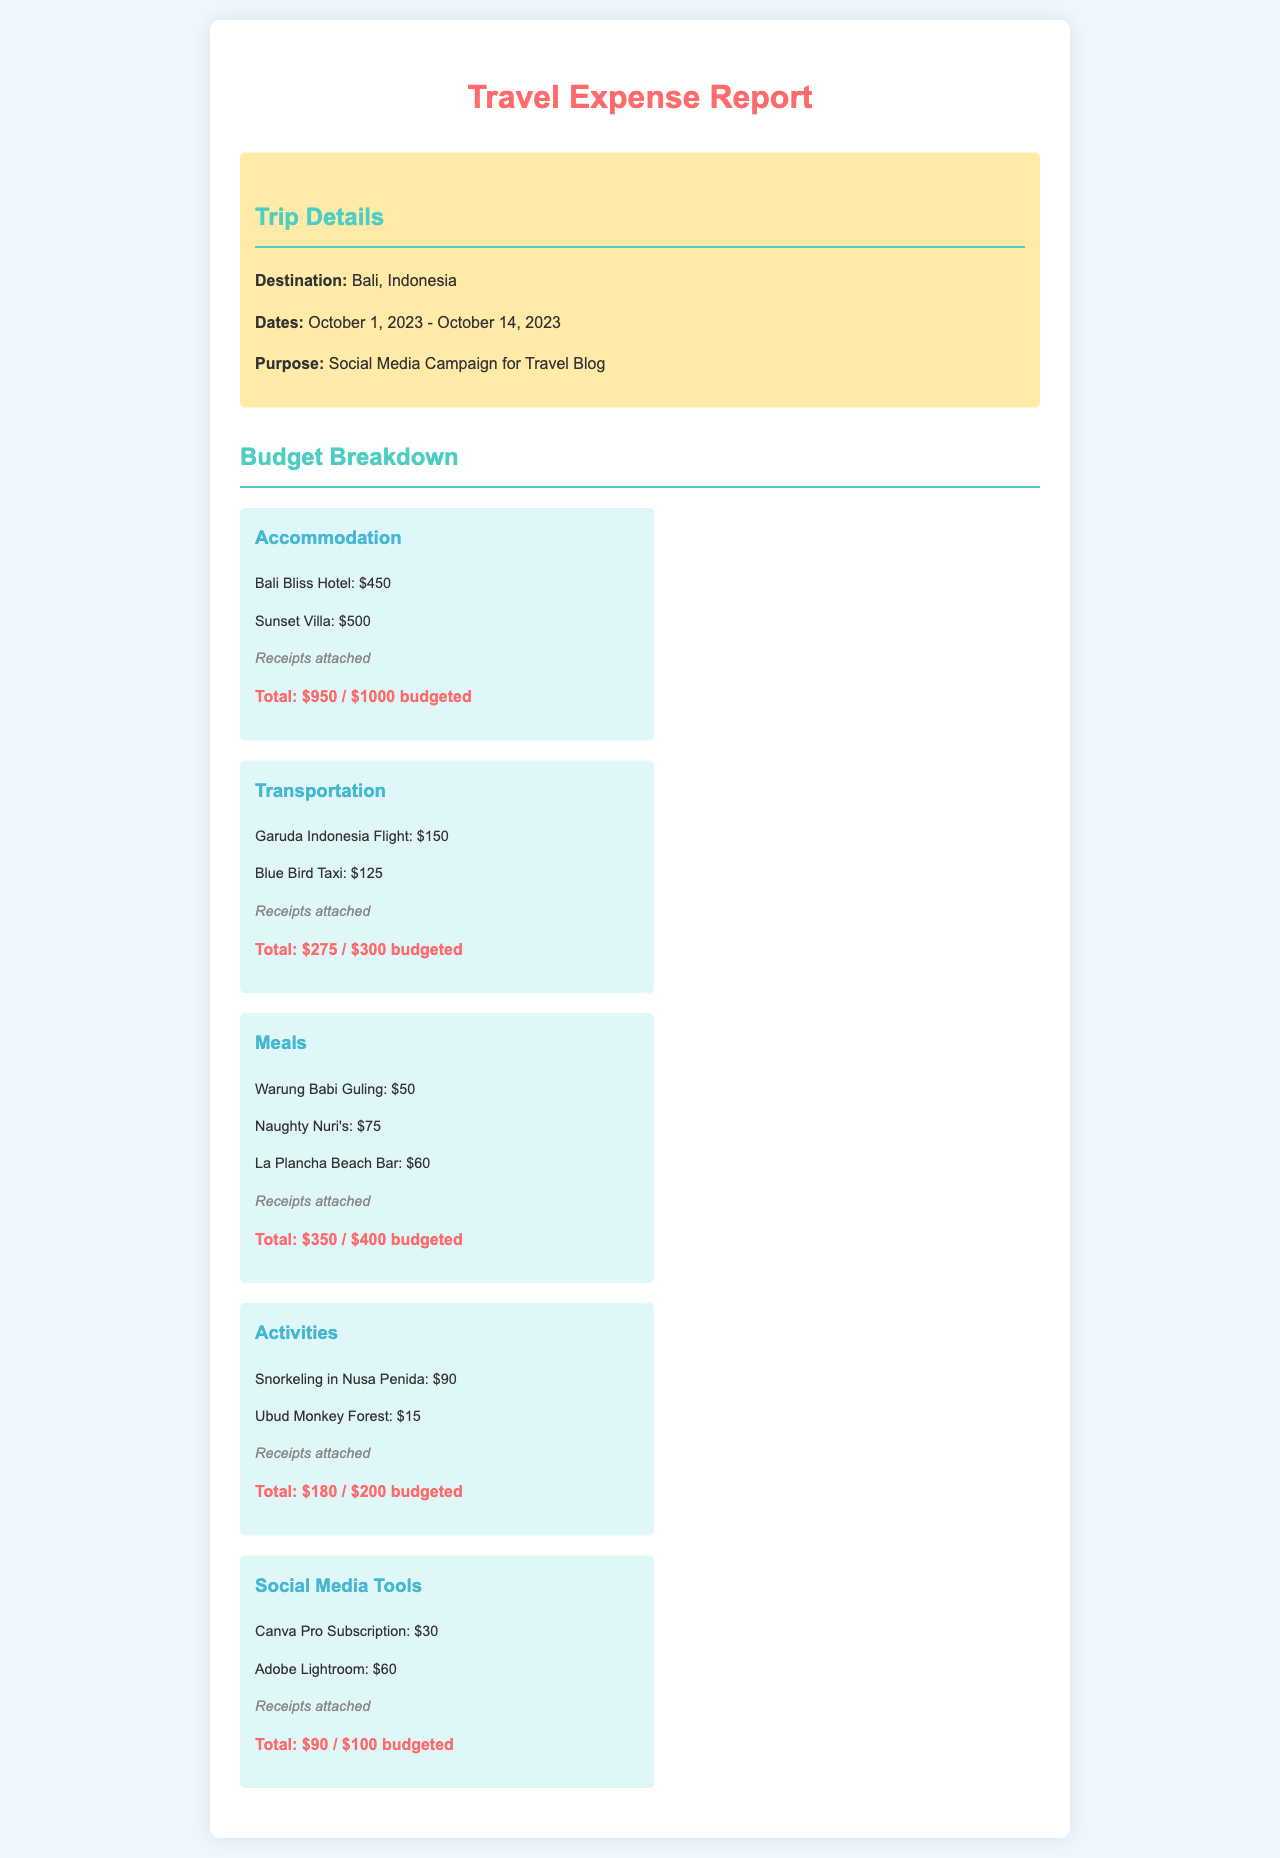What is the destination of the trip? The document specifies the destination of the trip, which is Bali, Indonesia.
Answer: Bali, Indonesia What are the dates of the trip? The trip dates are provided in the document as October 1, 2023 - October 14, 2023.
Answer: October 1, 2023 - October 14, 2023 What is the total cost of accommodation? The total cost for accommodation is detailed in the breakdown, which is $950.
Answer: $950 How much was spent on meals? The budget breakdown indicates that $350 was spent on meals during the trip.
Answer: $350 What was the budget allocated for transportation? The document shows that $300 was budgeted for transportation.
Answer: $300 Which activity cost the least? The cheapest activity listed is the Ubud Monkey Forest, which cost $15.
Answer: $15 What is the total budget set for the trip? The document does not specify a total budget for the entire trip but lists individual budgets for categories.
Answer: Not specified How much was spent on Social Media Tools? The total amount spent on Social Media Tools, as mentioned in the document, is $90.
Answer: $90 Is there a receipt status mentioned for the accommodation expenses? The document notes that receipts are attached for accommodation expenses.
Answer: Receipts attached 